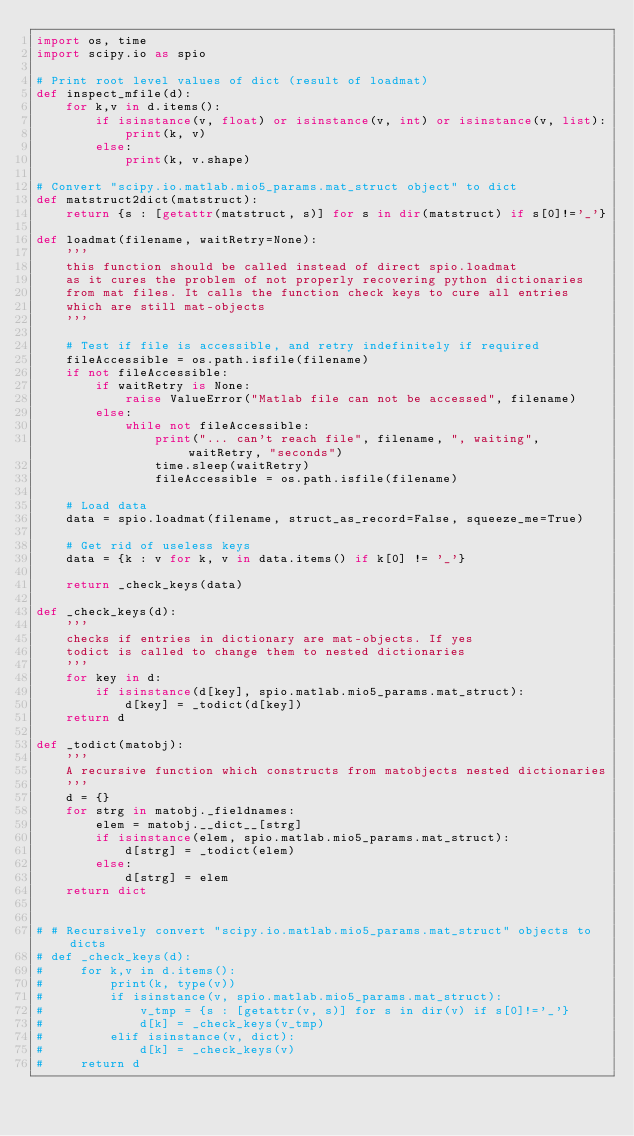<code> <loc_0><loc_0><loc_500><loc_500><_Python_>import os, time
import scipy.io as spio

# Print root level values of dict (result of loadmat)
def inspect_mfile(d):
    for k,v in d.items():
        if isinstance(v, float) or isinstance(v, int) or isinstance(v, list):
            print(k, v)
        else:
            print(k, v.shape)

# Convert "scipy.io.matlab.mio5_params.mat_struct object" to dict
def matstruct2dict(matstruct):
    return {s : [getattr(matstruct, s)] for s in dir(matstruct) if s[0]!='_'}

def loadmat(filename, waitRetry=None):
    '''
    this function should be called instead of direct spio.loadmat
    as it cures the problem of not properly recovering python dictionaries
    from mat files. It calls the function check keys to cure all entries
    which are still mat-objects
    '''
    
    # Test if file is accessible, and retry indefinitely if required
    fileAccessible = os.path.isfile(filename)
    if not fileAccessible:
        if waitRetry is None:
            raise ValueError("Matlab file can not be accessed", filename)
        else:
            while not fileAccessible:
                print("... can't reach file", filename, ", waiting", waitRetry, "seconds")
                time.sleep(waitRetry)
                fileAccessible = os.path.isfile(filename)

    # Load data
    data = spio.loadmat(filename, struct_as_record=False, squeeze_me=True)
    
    # Get rid of useless keys
    data = {k : v for k, v in data.items() if k[0] != '_'}
    
    return _check_keys(data)

def _check_keys(d):
    '''
    checks if entries in dictionary are mat-objects. If yes
    todict is called to change them to nested dictionaries
    '''
    for key in d:
        if isinstance(d[key], spio.matlab.mio5_params.mat_struct):
            d[key] = _todict(d[key])
    return d        

def _todict(matobj):
    '''
    A recursive function which constructs from matobjects nested dictionaries
    '''
    d = {}
    for strg in matobj._fieldnames:
        elem = matobj.__dict__[strg]
        if isinstance(elem, spio.matlab.mio5_params.mat_struct):
            d[strg] = _todict(elem)
        else:
            d[strg] = elem
    return dict


# # Recursively convert "scipy.io.matlab.mio5_params.mat_struct" objects to dicts
# def _check_keys(d):
#     for k,v in d.items():
#         print(k, type(v))
#         if isinstance(v, spio.matlab.mio5_params.mat_struct):
#             v_tmp = {s : [getattr(v, s)] for s in dir(v) if s[0]!='_'}
#             d[k] = _check_keys(v_tmp)
#         elif isinstance(v, dict):
#             d[k] = _check_keys(v)
#     return d</code> 